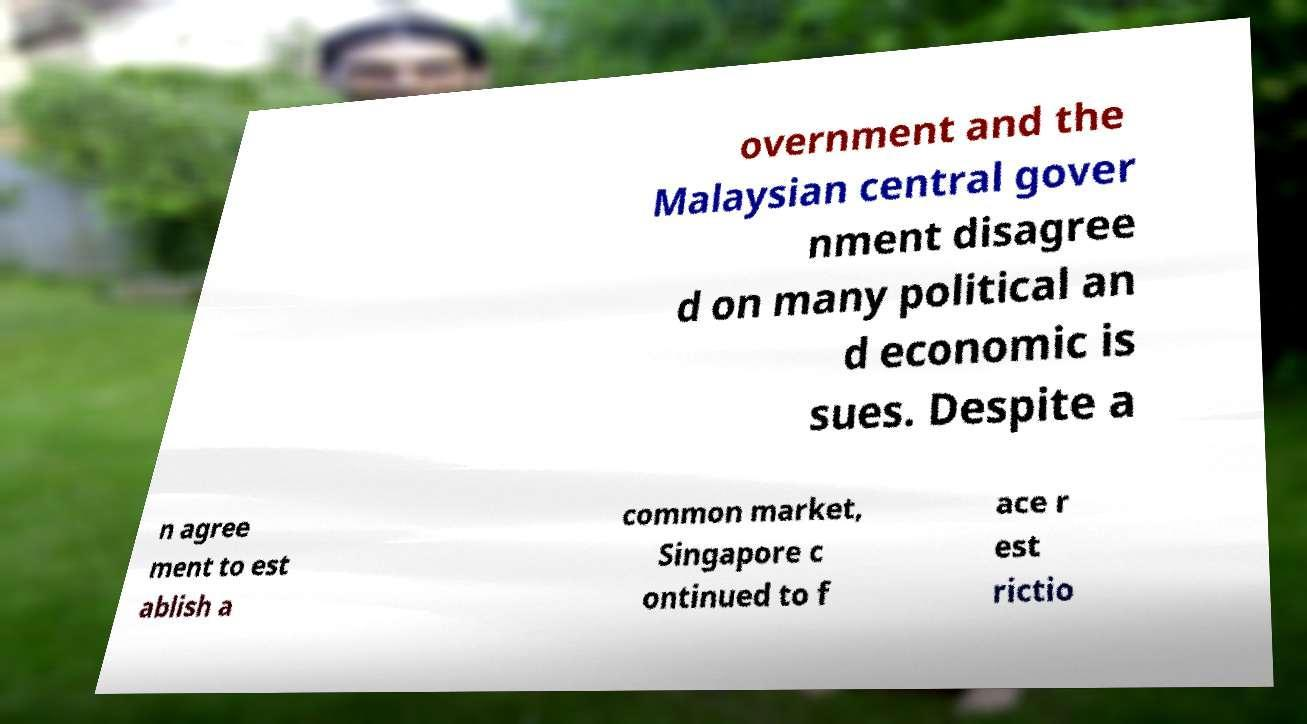Could you extract and type out the text from this image? overnment and the Malaysian central gover nment disagree d on many political an d economic is sues. Despite a n agree ment to est ablish a common market, Singapore c ontinued to f ace r est rictio 